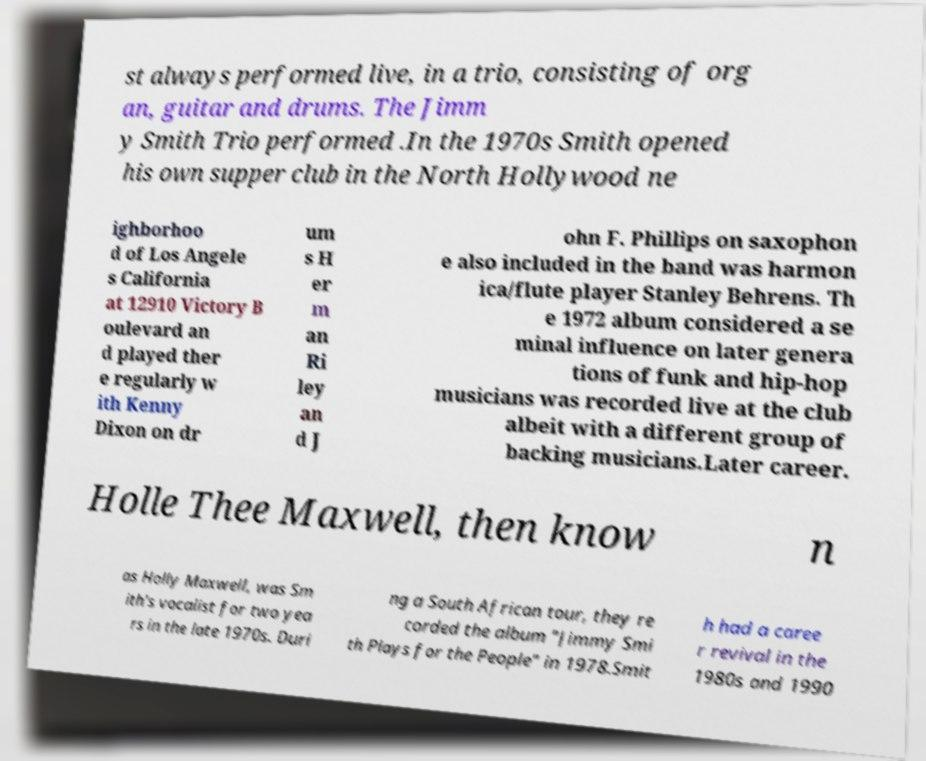What messages or text are displayed in this image? I need them in a readable, typed format. st always performed live, in a trio, consisting of org an, guitar and drums. The Jimm y Smith Trio performed .In the 1970s Smith opened his own supper club in the North Hollywood ne ighborhoo d of Los Angele s California at 12910 Victory B oulevard an d played ther e regularly w ith Kenny Dixon on dr um s H er m an Ri ley an d J ohn F. Phillips on saxophon e also included in the band was harmon ica/flute player Stanley Behrens. Th e 1972 album considered a se minal influence on later genera tions of funk and hip-hop musicians was recorded live at the club albeit with a different group of backing musicians.Later career. Holle Thee Maxwell, then know n as Holly Maxwell, was Sm ith's vocalist for two yea rs in the late 1970s. Duri ng a South African tour, they re corded the album "Jimmy Smi th Plays for the People" in 1978.Smit h had a caree r revival in the 1980s and 1990 